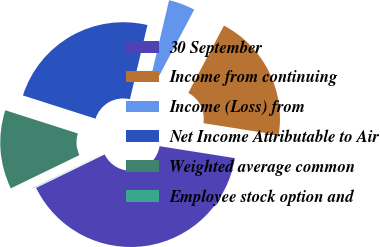Convert chart. <chart><loc_0><loc_0><loc_500><loc_500><pie_chart><fcel>30 September<fcel>Income from continuing<fcel>Income (Loss) from<fcel>Net Income Attributable to Air<fcel>Weighted average common<fcel>Employee stock option and<nl><fcel>40.27%<fcel>19.74%<fcel>4.07%<fcel>23.76%<fcel>12.12%<fcel>0.05%<nl></chart> 